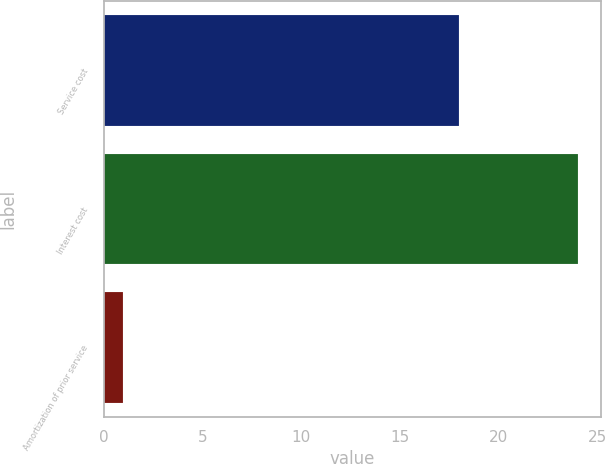<chart> <loc_0><loc_0><loc_500><loc_500><bar_chart><fcel>Service cost<fcel>Interest cost<fcel>Amortization of prior service<nl><fcel>18<fcel>24<fcel>1<nl></chart> 